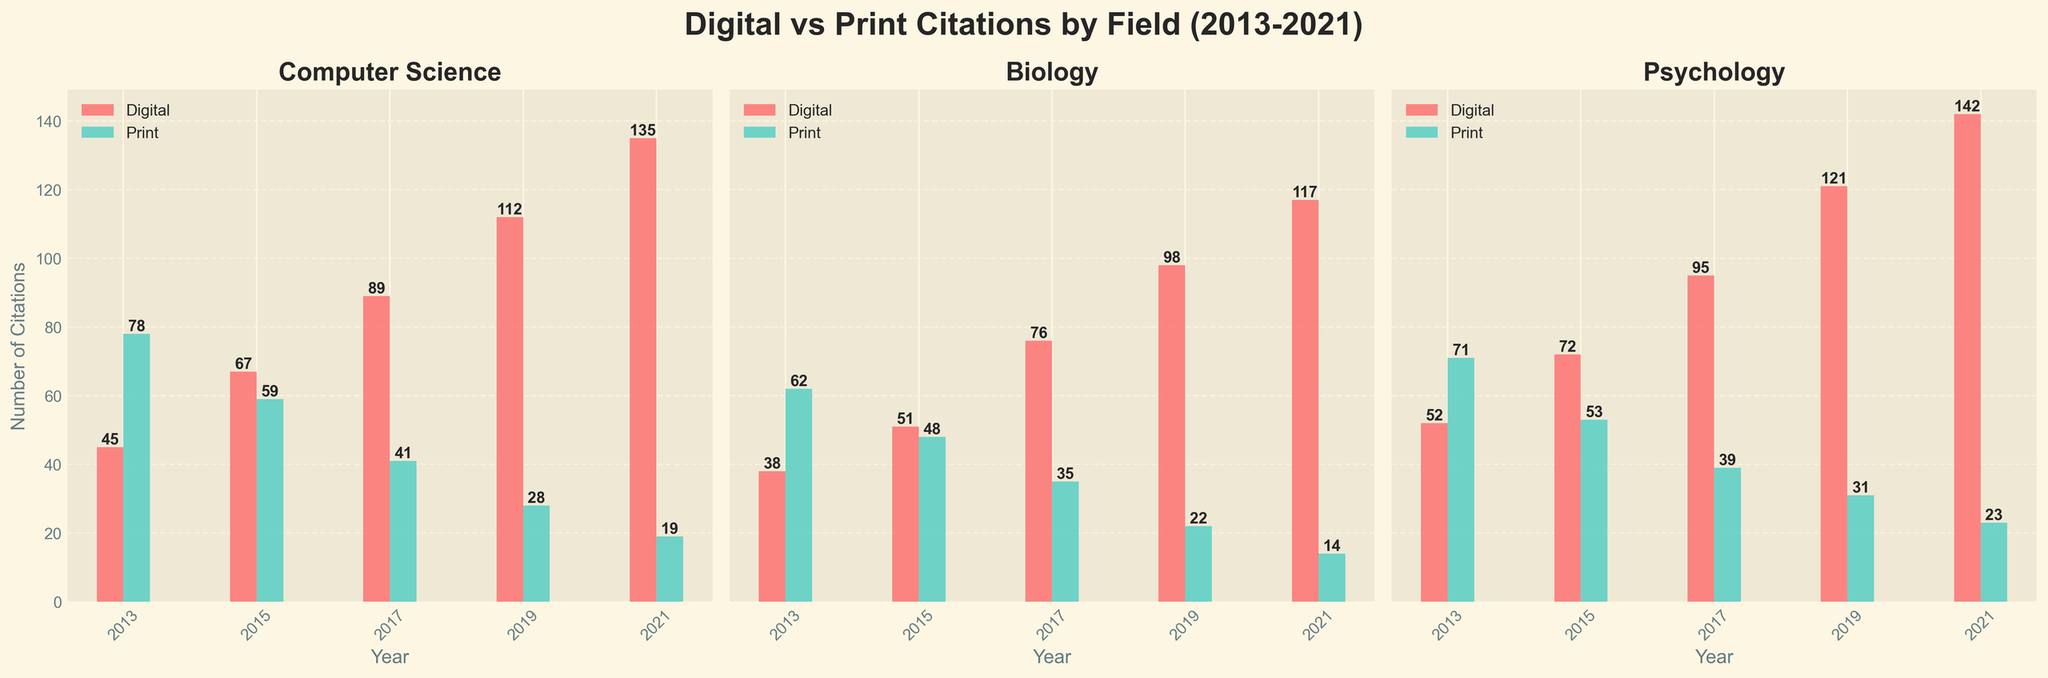How many total citation types are compared in the figure? The figure compares digital and print citation types across different fields. Two citation types are represented by distinct colors in the bar charts for each year and field.
Answer: Two Which field had the highest number of digital citations in 2021? In the subplot for 2021, each field shows digital citations in red bars. For Computer Science, the digital citations are 135. For Biology, it’s 117, and for Psychology, it’s 142. Thus, Psychology had the highest digital citations.
Answer: Psychology What is the trend of print citations for the fields from 2013 to 2021? Observing the print citations (green bars) over the years for each field in the subplots: For Computer Science, Biology, and Psychology, the print citations are consistently decreasing from 2013 to 2021.
Answer: Decreasing Comparing 2015, which field saw a larger increase in digital citations by 2017: Computer Science or Biology? In 2015, Computer Science had 67 digital citations and increased to 89 in 2017. The increase is 22 citations. For Biology, digital citations increased from 51 in 2015 to 76 in 2017, an increase of 25 citations. Therefore, Biology saw a larger increase.
Answer: Biology Which year shows the highest total citations (digital and print combined) for the Psychology field? By summing the digital and print citations for each year in Psychology: 
2013: 52+71 = 123
2015: 72+53 = 125
2017: 95+39 = 134
2019: 121+31 = 152
2021: 142+23 = 165
2021 has the highest total citations, summing up to 165.
Answer: 2021 Which field had the lowest print citations in 2019 and what was the count? In the subplot for 2019, each field shows print citations in green bars. For Computer Science, the print citations are 28. For Biology, it’s 22. For Psychology, it’s 31. Thus, Biology had the lowest print citations with a count of 22.
Answer: Biology, 22 By how much did digital citations in Biology increase from 2013 to 2021? In 2013, Biology had 38 digital citations, and by 2021, it had 117. The increase is calculated as 117 - 38 = 79.
Answer: 79 What is the average number of print citations for Computer Science from 2013 to 2021? Print citations for Computer Science from 2013 to 2021 are: 78, 59, 41, 28, 19. The sum is 225, and there are 5 data points. The average is 225 / 5 = 45.
Answer: 45 Which field had a greater reduction in print citations from its peak to its lowest recorded value between 2013 and 2021: Computer Science or Psychology? For Computer Science, the peak print citations are 78 (2013) and the lowest is 19 (2021), a reduction of 59. For Psychology, the peak print citations are 71 (2013) and the lowest is 23 (2021), a reduction of 48. Thus, Computer Science had a greater reduction.
Answer: Computer Science 